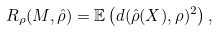Convert formula to latex. <formula><loc_0><loc_0><loc_500><loc_500>R _ { \rho } ( M , \hat { \rho } ) = \mathbb { E } \left ( d ( \hat { \rho } ( X ) , \rho ) ^ { 2 } \right ) ,</formula> 